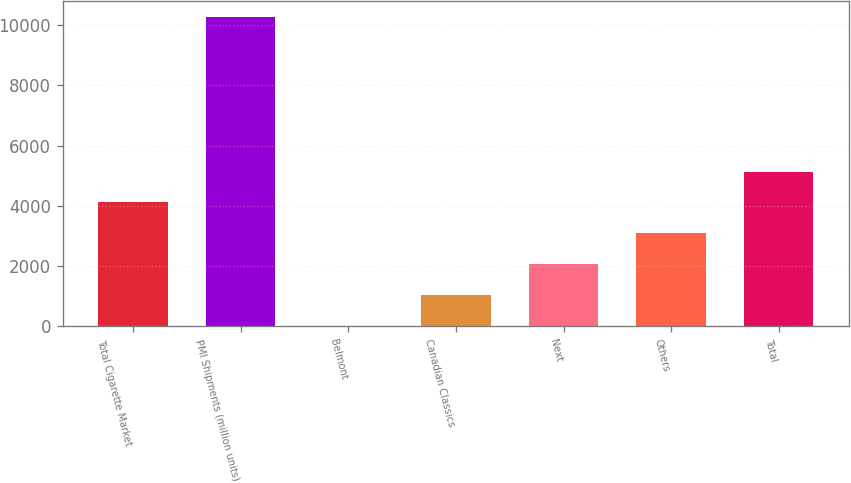Convert chart. <chart><loc_0><loc_0><loc_500><loc_500><bar_chart><fcel>Total Cigarette Market<fcel>PMI Shipments (million units)<fcel>Belmont<fcel>Canadian Classics<fcel>Next<fcel>Others<fcel>Total<nl><fcel>4111.8<fcel>10275<fcel>3<fcel>1030.2<fcel>2057.4<fcel>3084.6<fcel>5139<nl></chart> 